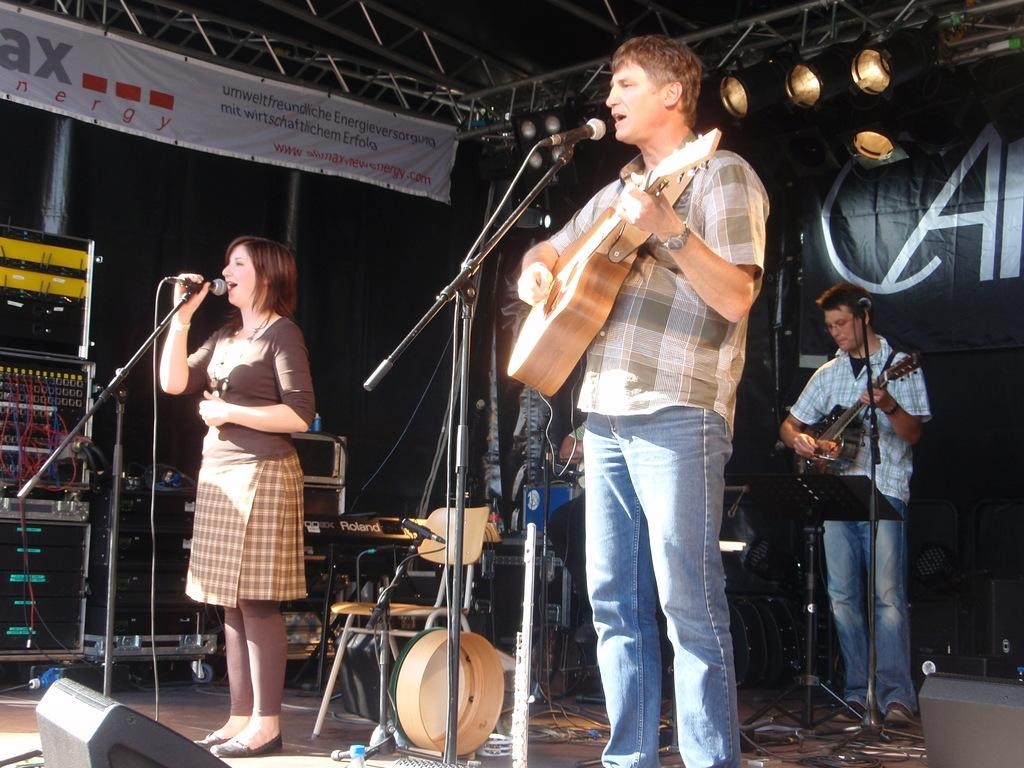How many people are present in the image? There are three people standing in the image. What are two of the people doing in the image? Two men are playing guitar. What is the third person doing in the image? A woman is singing with the help of a microphone. What type of goldfish can be seen swimming in the background of the image? There are no goldfish present in the image; it features three people, two of whom are playing guitar and one is singing with a microphone. 